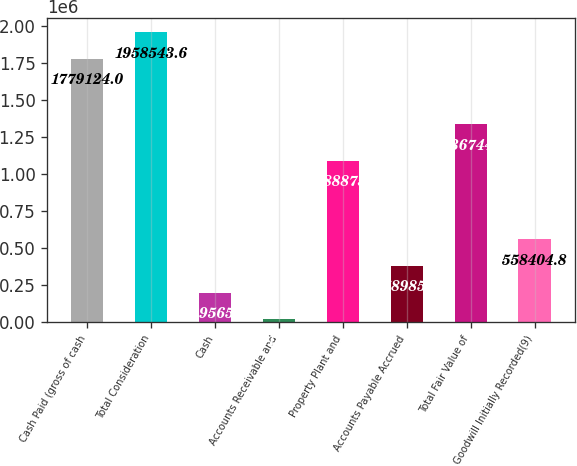Convert chart. <chart><loc_0><loc_0><loc_500><loc_500><bar_chart><fcel>Cash Paid (gross of cash<fcel>Total Consideration<fcel>Cash<fcel>Accounts Receivable and<fcel>Property Plant and<fcel>Accounts Payable Accrued<fcel>Total Fair Value of<fcel>Goodwill Initially Recorded(9)<nl><fcel>1.77912e+06<fcel>1.95854e+06<fcel>199566<fcel>20146<fcel>1.08888e+06<fcel>378985<fcel>1.33674e+06<fcel>558405<nl></chart> 